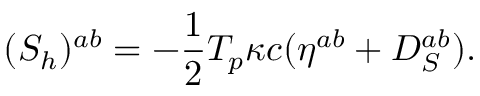Convert formula to latex. <formula><loc_0><loc_0><loc_500><loc_500>( { S } _ { h } ) ^ { a b } = { - { \frac { 1 } { 2 } } T _ { p } \kappa c } ( \eta ^ { a b } + D _ { S } ^ { a b } ) .</formula> 